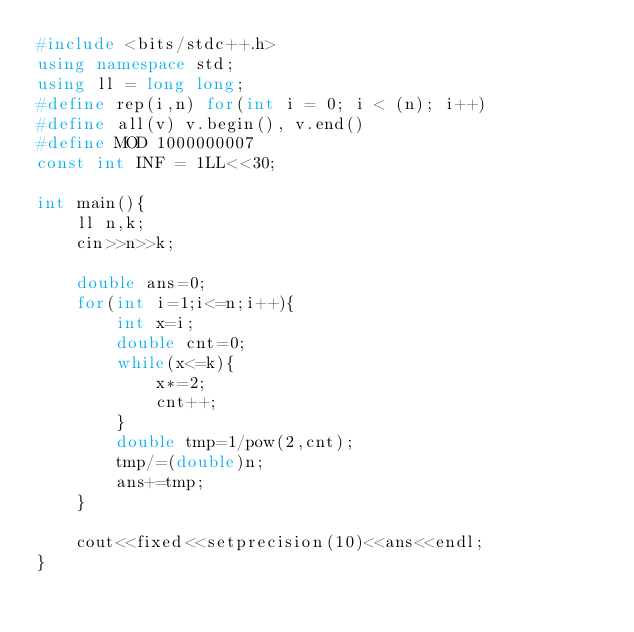<code> <loc_0><loc_0><loc_500><loc_500><_C++_>#include <bits/stdc++.h>
using namespace std;
using ll = long long;
#define rep(i,n) for(int i = 0; i < (n); i++)
#define all(v) v.begin(), v.end()
#define MOD 1000000007
const int INF = 1LL<<30;
 
int main(){
    ll n,k;
    cin>>n>>k;

    double ans=0;
    for(int i=1;i<=n;i++){
        int x=i;
        double cnt=0;
        while(x<=k){
            x*=2;
            cnt++;
        }
        double tmp=1/pow(2,cnt);
        tmp/=(double)n;
        ans+=tmp;
    }

    cout<<fixed<<setprecision(10)<<ans<<endl;
}</code> 